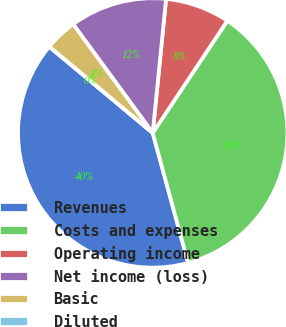Convert chart. <chart><loc_0><loc_0><loc_500><loc_500><pie_chart><fcel>Revenues<fcel>Costs and expenses<fcel>Operating income<fcel>Net income (loss)<fcel>Basic<fcel>Diluted<nl><fcel>40.3%<fcel>36.43%<fcel>7.76%<fcel>11.64%<fcel>3.88%<fcel>0.0%<nl></chart> 